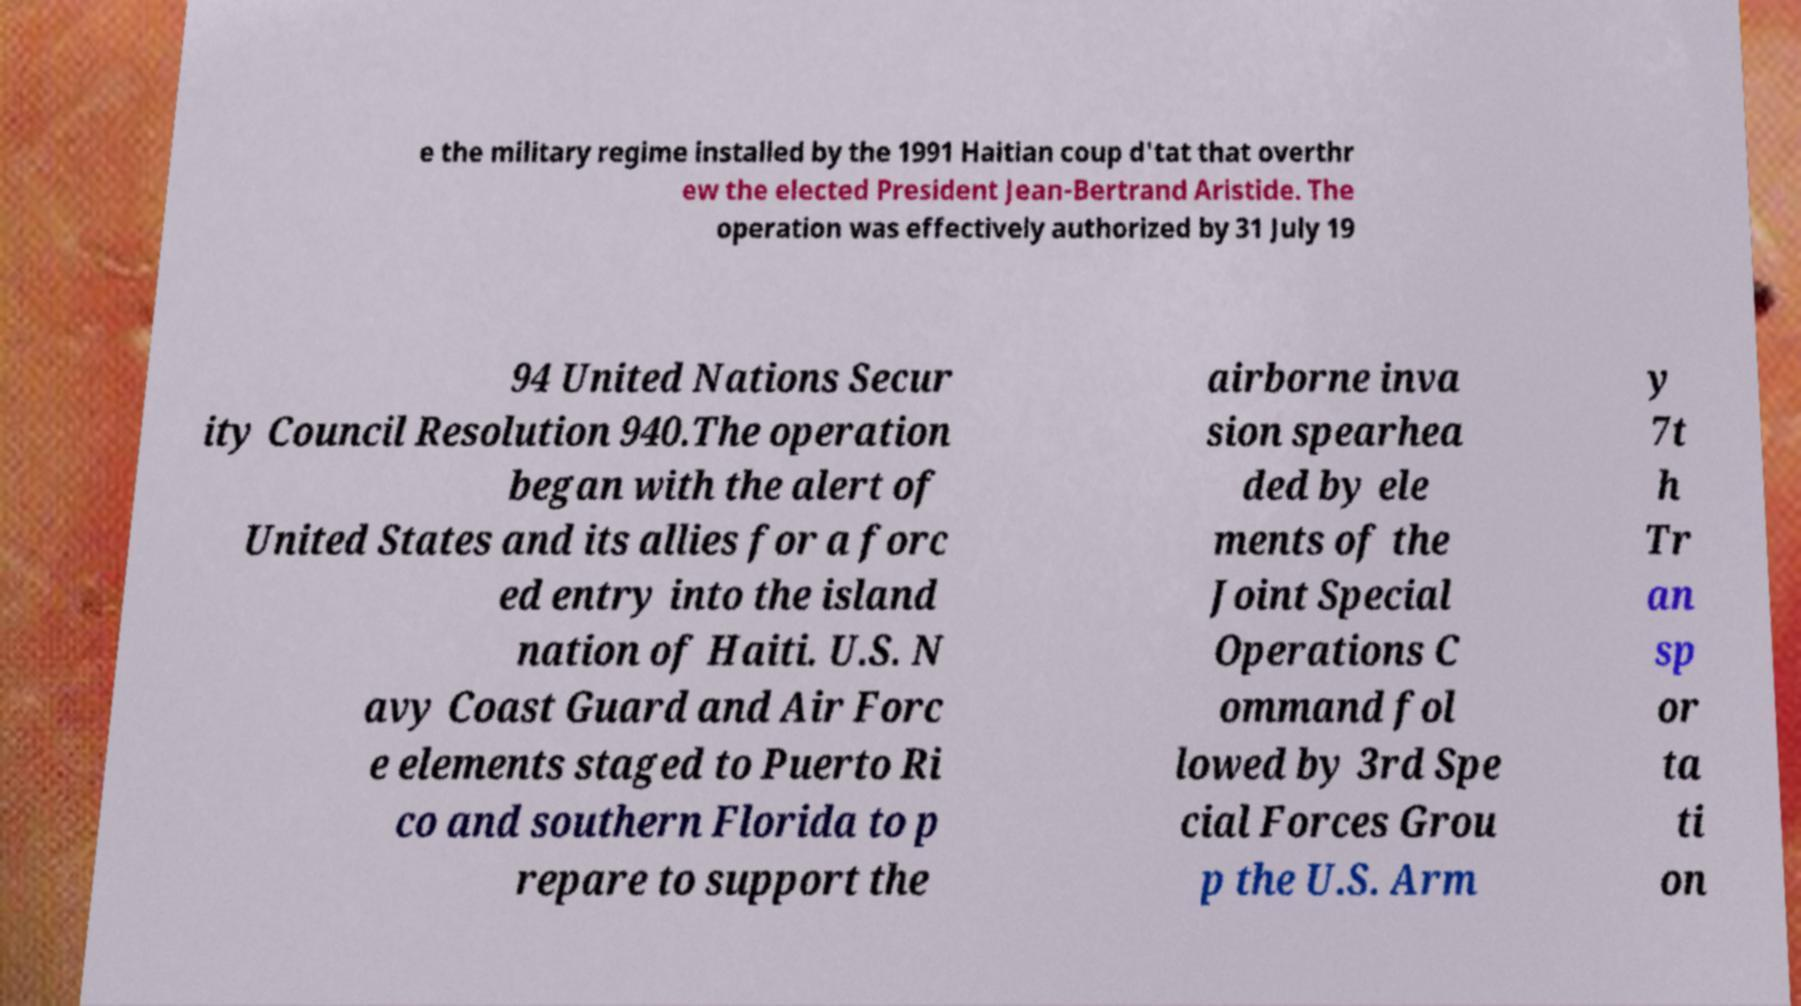Can you read and provide the text displayed in the image?This photo seems to have some interesting text. Can you extract and type it out for me? e the military regime installed by the 1991 Haitian coup d'tat that overthr ew the elected President Jean-Bertrand Aristide. The operation was effectively authorized by 31 July 19 94 United Nations Secur ity Council Resolution 940.The operation began with the alert of United States and its allies for a forc ed entry into the island nation of Haiti. U.S. N avy Coast Guard and Air Forc e elements staged to Puerto Ri co and southern Florida to p repare to support the airborne inva sion spearhea ded by ele ments of the Joint Special Operations C ommand fol lowed by 3rd Spe cial Forces Grou p the U.S. Arm y 7t h Tr an sp or ta ti on 